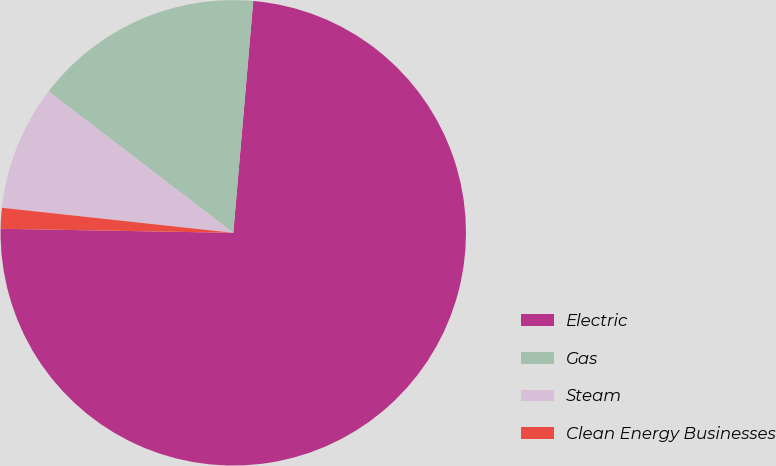Convert chart. <chart><loc_0><loc_0><loc_500><loc_500><pie_chart><fcel>Electric<fcel>Gas<fcel>Steam<fcel>Clean Energy Businesses<nl><fcel>73.91%<fcel>15.97%<fcel>8.68%<fcel>1.44%<nl></chart> 